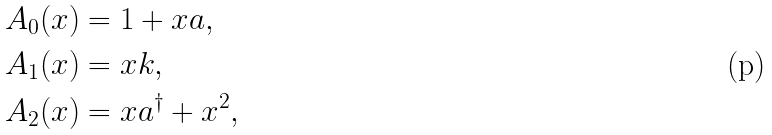<formula> <loc_0><loc_0><loc_500><loc_500>A _ { 0 } ( x ) & = 1 + x a , \\ A _ { 1 } ( x ) & = x k , \\ A _ { 2 } ( x ) & = x a ^ { \dag } + x ^ { 2 } ,</formula> 